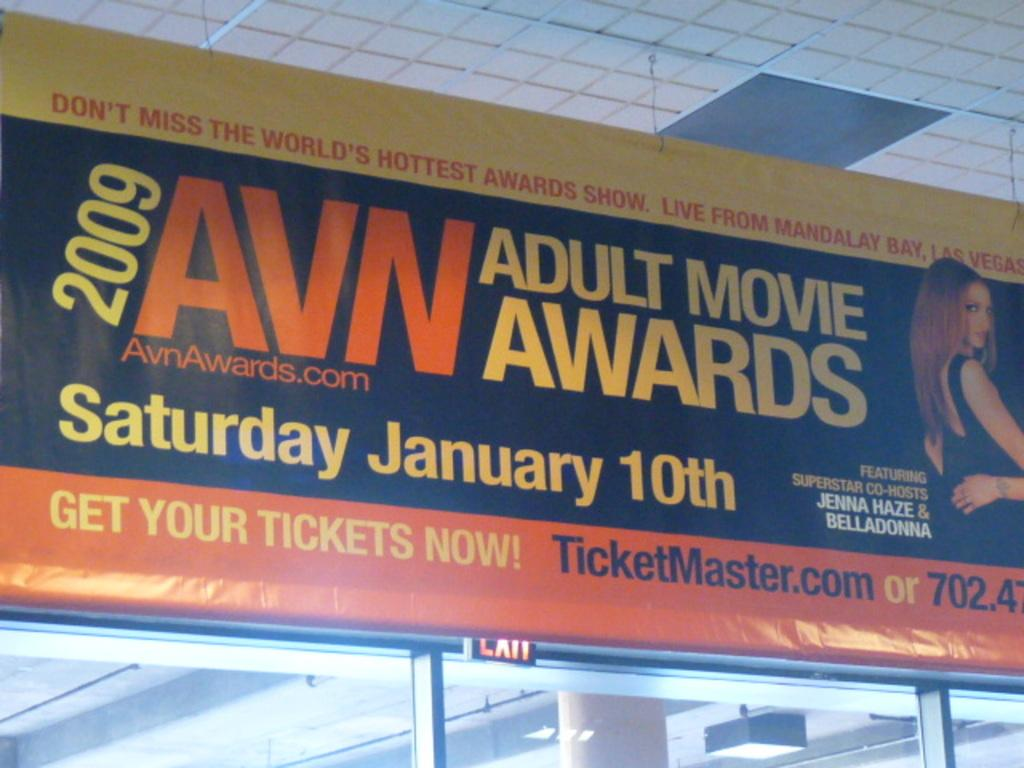Provide a one-sentence caption for the provided image. An advertisement for the 2009 adult movie awards. 